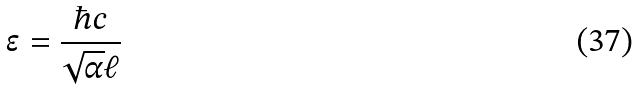<formula> <loc_0><loc_0><loc_500><loc_500>\epsilon = \frac { \hbar { c } } { \sqrt { \alpha } \ell }</formula> 